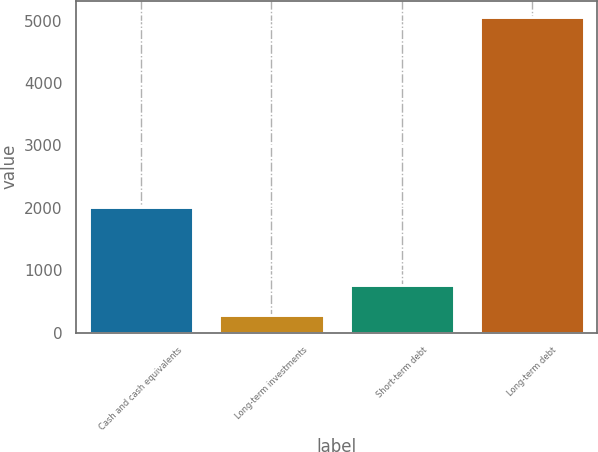Convert chart. <chart><loc_0><loc_0><loc_500><loc_500><bar_chart><fcel>Cash and cash equivalents<fcel>Long-term investments<fcel>Short-term debt<fcel>Long-term debt<nl><fcel>2020<fcel>277<fcel>755.5<fcel>5062<nl></chart> 